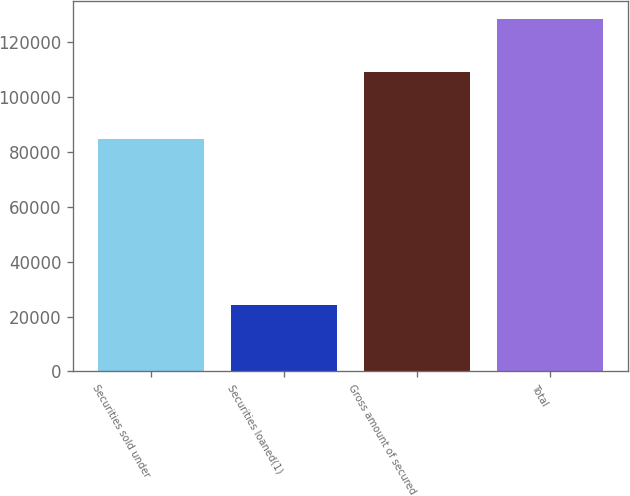Convert chart. <chart><loc_0><loc_0><loc_500><loc_500><bar_chart><fcel>Securities sold under<fcel>Securities loaned(1)<fcel>Gross amount of secured<fcel>Total<nl><fcel>84749<fcel>24387<fcel>109136<fcel>128452<nl></chart> 